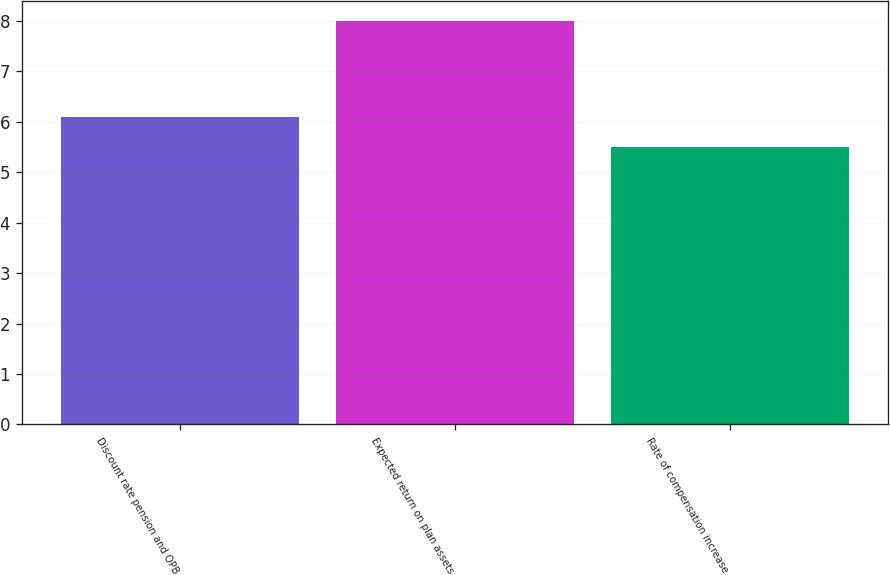<chart> <loc_0><loc_0><loc_500><loc_500><bar_chart><fcel>Discount rate pension and OPB<fcel>Expected return on plan assets<fcel>Rate of compensation increase<nl><fcel>6.1<fcel>8<fcel>5.5<nl></chart> 